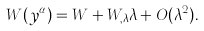<formula> <loc_0><loc_0><loc_500><loc_500>W ( y ^ { \alpha } ) = W + W _ { , \lambda } \lambda + O ( \lambda ^ { 2 } ) .</formula> 